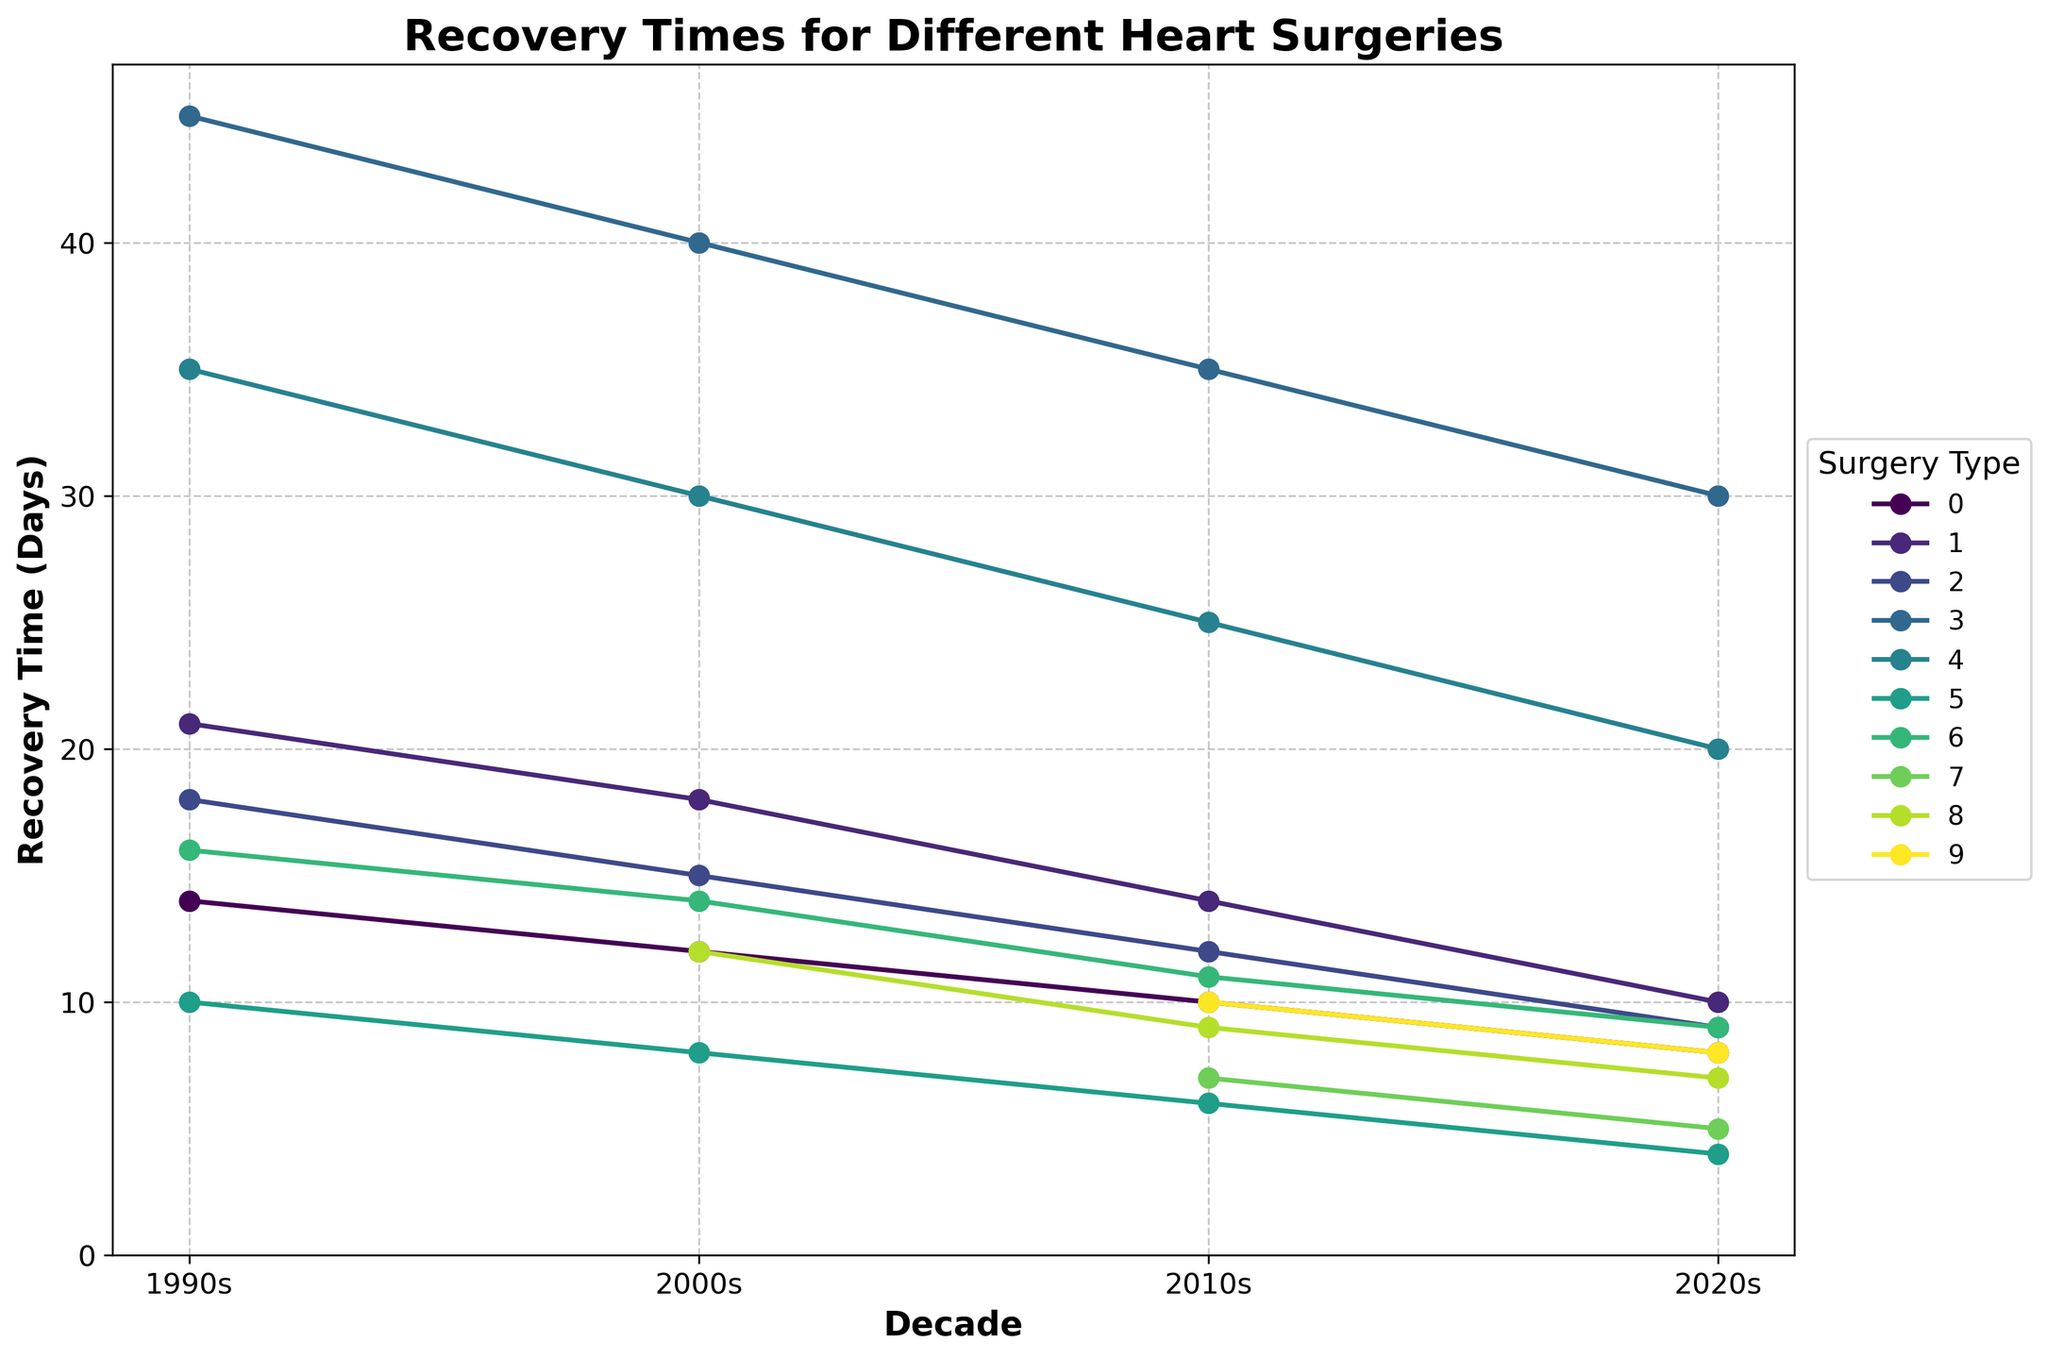What is the surgery with the shortest recovery time in the 2020s? By looking at the figure, identify the surgery type with the lowest recovery time point on the line chart in the 2020s. The shortest recovery time in the 2020s can be seen directly.
Answer: Atrial Septal Defect Closure Which two surgeries showed the greatest decrease in recovery time from the 1990s to the 2020s? To determine this, calculate the difference between the recovery times in the 1990s and 2020s for each surgery, and then identify the two surgeries with the largest decreases. The calculations yield: 
Coronary Artery Bypass Grafting: 14 - 8 = 6
Aortic Valve Replacement: 21 - 10 = 11
Mitral Valve Repair: 18 - 9 = 9
Heart Transplant: 45 - 30 = 15
Ventricular Assist Device Implantation: 35 - 20 = 15
Atrial Septal Defect Closure: 10 - 4 = 6
Maze Procedure for Atrial Fibrillation: 16 - 9 = 7
The greatest decreases are in Heart Transplant and Ventricular Assist Device Implantation.
Answer: Heart Transplant and Ventricular Assist Device Implantation What is the average recovery time for Mitral Valve Repair spanning from the 1990s to the 2020s? Average recovery time can be calculated by adding the recovery times for all decades and dividing by the number of decades. For Mitral Valve Repair: 
(18 + 15 + 12 + 9) / 4 = 54 / 4 = 13.5
Answer: 13.5 Which surgery had the greatest recovery time improvement in the 2000s compared to the previous decade? Find the value difference for each surgery between the 1990s and the 2000s, then identify the largest improvement. Calculations are as follows:
Coronary Artery Bypass Grafting: 14 - 12 = 2
Aortic Valve Replacement: 21 - 18 = 3
Mitral Valve Repair: 18 - 15 = 3
Heart Transplant: 45 - 40 = 5
Ventricular Assist Device Implantation: 35 - 30 = 5
Atrial Septal Defect Closure: 10 - 8 = 2
Maze Procedure for Atrial Fibrillation: 16 - 14 = 2
Heart Transplant and Ventricular Assist Device Implantation each show a 5-day improvement.
Answer: Heart Transplant and Ventricular Assist Device Implantation Among the surgeries introduced in the 2010s and 2020s, which has the most significant reduction in recovery time from their introduction to the 2020s? Review the recovery times for 'Transcatheter Aortic Valve Replacement', 'Minimally Invasive Direct Coronary Artery Bypass', and 'Robotic-Assisted Mitral Valve Surgery', and calculate the difference between their introduction decade and the 2020s. The reductions are:
Transcatheter Aortic Valve Replacement: 7 - 5 = 2
Minimally Invasive Direct Coronary Artery Bypass: 12 - 7 = 5
Robotic-Assisted Mitral Valve Surgery: 10 - 8 = 2
The largest reduction is in Minimally Invasive Direct Coronary Artery Bypass.
Answer: Minimally Invasive Direct Coronary Artery Bypass Which surgery had a steady decline in recovery times across all decades? Examine each surgery's recovery times across all decades to identify consistent decreases. 'Coronary Artery Bypass Grafting', 'Aortic Valve Replacement', 'Mitral Valve Repair', 'Heart Transplant', 'Ventricular Assist Device Implantation', and 'Atrial Septal Defect Closure' all show steady decreases, but the requirement is for "all decades," so surgeries introduced in later decades are excluded.
Answer: Coronary Artery Bypass Grafting, Aortic Valve Replacement, Mitral Valve Repair, Heart Transplant, Ventricular Assist Device Implantation, Atrial Septal Defect Closure 